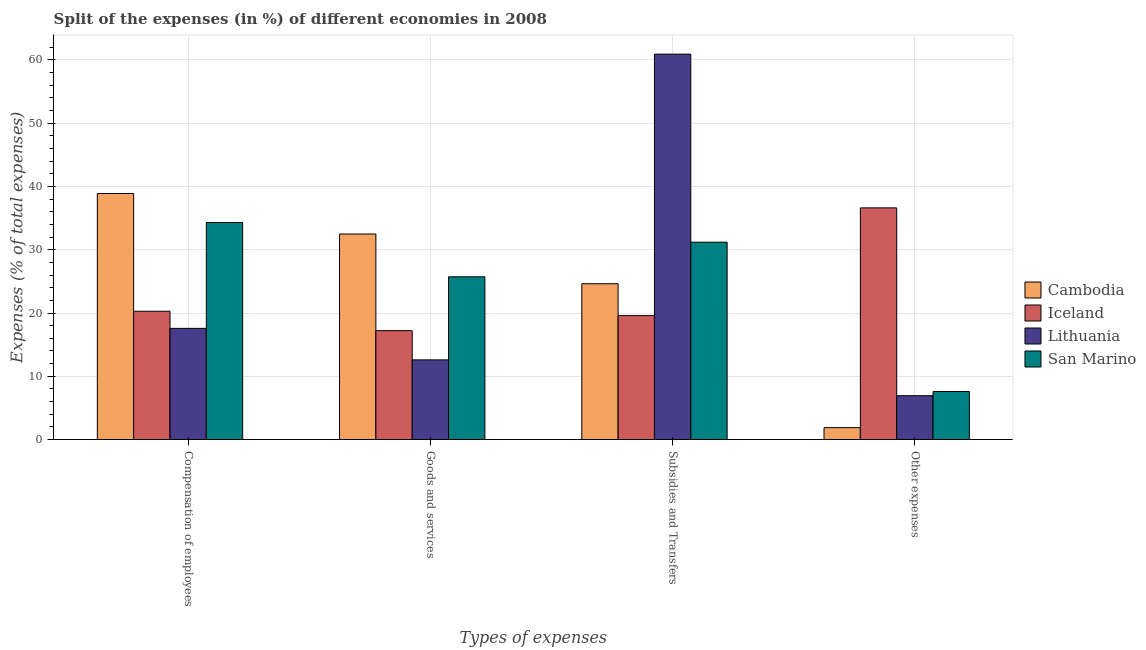How many different coloured bars are there?
Your answer should be very brief. 4. How many groups of bars are there?
Your answer should be very brief. 4. Are the number of bars per tick equal to the number of legend labels?
Your answer should be very brief. Yes. Are the number of bars on each tick of the X-axis equal?
Offer a very short reply. Yes. How many bars are there on the 4th tick from the right?
Provide a short and direct response. 4. What is the label of the 2nd group of bars from the left?
Your answer should be compact. Goods and services. What is the percentage of amount spent on subsidies in Lithuania?
Make the answer very short. 60.9. Across all countries, what is the maximum percentage of amount spent on other expenses?
Make the answer very short. 36.61. Across all countries, what is the minimum percentage of amount spent on subsidies?
Provide a succinct answer. 19.6. In which country was the percentage of amount spent on goods and services maximum?
Ensure brevity in your answer.  Cambodia. In which country was the percentage of amount spent on goods and services minimum?
Provide a succinct answer. Lithuania. What is the total percentage of amount spent on other expenses in the graph?
Give a very brief answer. 53.04. What is the difference between the percentage of amount spent on subsidies in Lithuania and that in Cambodia?
Ensure brevity in your answer.  36.27. What is the difference between the percentage of amount spent on other expenses in Iceland and the percentage of amount spent on goods and services in Cambodia?
Make the answer very short. 4.13. What is the average percentage of amount spent on compensation of employees per country?
Provide a succinct answer. 27.76. What is the difference between the percentage of amount spent on other expenses and percentage of amount spent on subsidies in Iceland?
Your response must be concise. 17.02. What is the ratio of the percentage of amount spent on goods and services in Cambodia to that in Iceland?
Provide a short and direct response. 1.89. Is the percentage of amount spent on goods and services in San Marino less than that in Lithuania?
Give a very brief answer. No. What is the difference between the highest and the second highest percentage of amount spent on goods and services?
Your answer should be very brief. 6.76. What is the difference between the highest and the lowest percentage of amount spent on compensation of employees?
Ensure brevity in your answer.  21.31. Is it the case that in every country, the sum of the percentage of amount spent on compensation of employees and percentage of amount spent on other expenses is greater than the sum of percentage of amount spent on subsidies and percentage of amount spent on goods and services?
Provide a succinct answer. No. What does the 3rd bar from the left in Goods and services represents?
Keep it short and to the point. Lithuania. What does the 1st bar from the right in Goods and services represents?
Provide a succinct answer. San Marino. How many countries are there in the graph?
Your answer should be compact. 4. Are the values on the major ticks of Y-axis written in scientific E-notation?
Offer a very short reply. No. Does the graph contain grids?
Make the answer very short. Yes. How many legend labels are there?
Ensure brevity in your answer.  4. What is the title of the graph?
Your response must be concise. Split of the expenses (in %) of different economies in 2008. Does "Jordan" appear as one of the legend labels in the graph?
Ensure brevity in your answer.  No. What is the label or title of the X-axis?
Ensure brevity in your answer.  Types of expenses. What is the label or title of the Y-axis?
Your answer should be compact. Expenses (% of total expenses). What is the Expenses (% of total expenses) in Cambodia in Compensation of employees?
Your response must be concise. 38.88. What is the Expenses (% of total expenses) of Iceland in Compensation of employees?
Give a very brief answer. 20.28. What is the Expenses (% of total expenses) of Lithuania in Compensation of employees?
Keep it short and to the point. 17.57. What is the Expenses (% of total expenses) of San Marino in Compensation of employees?
Your answer should be compact. 34.3. What is the Expenses (% of total expenses) in Cambodia in Goods and services?
Make the answer very short. 32.48. What is the Expenses (% of total expenses) of Iceland in Goods and services?
Keep it short and to the point. 17.22. What is the Expenses (% of total expenses) in Lithuania in Goods and services?
Make the answer very short. 12.6. What is the Expenses (% of total expenses) in San Marino in Goods and services?
Give a very brief answer. 25.72. What is the Expenses (% of total expenses) of Cambodia in Subsidies and Transfers?
Keep it short and to the point. 24.63. What is the Expenses (% of total expenses) in Iceland in Subsidies and Transfers?
Your response must be concise. 19.6. What is the Expenses (% of total expenses) of Lithuania in Subsidies and Transfers?
Ensure brevity in your answer.  60.9. What is the Expenses (% of total expenses) in San Marino in Subsidies and Transfers?
Provide a succinct answer. 31.19. What is the Expenses (% of total expenses) in Cambodia in Other expenses?
Ensure brevity in your answer.  1.89. What is the Expenses (% of total expenses) of Iceland in Other expenses?
Give a very brief answer. 36.61. What is the Expenses (% of total expenses) of Lithuania in Other expenses?
Offer a terse response. 6.94. What is the Expenses (% of total expenses) of San Marino in Other expenses?
Ensure brevity in your answer.  7.6. Across all Types of expenses, what is the maximum Expenses (% of total expenses) in Cambodia?
Offer a terse response. 38.88. Across all Types of expenses, what is the maximum Expenses (% of total expenses) in Iceland?
Offer a very short reply. 36.61. Across all Types of expenses, what is the maximum Expenses (% of total expenses) in Lithuania?
Provide a short and direct response. 60.9. Across all Types of expenses, what is the maximum Expenses (% of total expenses) of San Marino?
Offer a terse response. 34.3. Across all Types of expenses, what is the minimum Expenses (% of total expenses) in Cambodia?
Keep it short and to the point. 1.89. Across all Types of expenses, what is the minimum Expenses (% of total expenses) in Iceland?
Offer a very short reply. 17.22. Across all Types of expenses, what is the minimum Expenses (% of total expenses) of Lithuania?
Keep it short and to the point. 6.94. Across all Types of expenses, what is the minimum Expenses (% of total expenses) in San Marino?
Offer a very short reply. 7.6. What is the total Expenses (% of total expenses) of Cambodia in the graph?
Provide a succinct answer. 97.88. What is the total Expenses (% of total expenses) of Iceland in the graph?
Give a very brief answer. 93.7. What is the total Expenses (% of total expenses) of Lithuania in the graph?
Keep it short and to the point. 98.01. What is the total Expenses (% of total expenses) of San Marino in the graph?
Offer a terse response. 98.81. What is the difference between the Expenses (% of total expenses) in Cambodia in Compensation of employees and that in Goods and services?
Ensure brevity in your answer.  6.4. What is the difference between the Expenses (% of total expenses) of Iceland in Compensation of employees and that in Goods and services?
Give a very brief answer. 3.06. What is the difference between the Expenses (% of total expenses) in Lithuania in Compensation of employees and that in Goods and services?
Keep it short and to the point. 4.98. What is the difference between the Expenses (% of total expenses) in San Marino in Compensation of employees and that in Goods and services?
Give a very brief answer. 8.58. What is the difference between the Expenses (% of total expenses) in Cambodia in Compensation of employees and that in Subsidies and Transfers?
Your response must be concise. 14.25. What is the difference between the Expenses (% of total expenses) of Iceland in Compensation of employees and that in Subsidies and Transfers?
Ensure brevity in your answer.  0.68. What is the difference between the Expenses (% of total expenses) in Lithuania in Compensation of employees and that in Subsidies and Transfers?
Provide a succinct answer. -43.33. What is the difference between the Expenses (% of total expenses) of San Marino in Compensation of employees and that in Subsidies and Transfers?
Provide a succinct answer. 3.11. What is the difference between the Expenses (% of total expenses) of Cambodia in Compensation of employees and that in Other expenses?
Your response must be concise. 37. What is the difference between the Expenses (% of total expenses) of Iceland in Compensation of employees and that in Other expenses?
Offer a very short reply. -16.33. What is the difference between the Expenses (% of total expenses) of Lithuania in Compensation of employees and that in Other expenses?
Provide a short and direct response. 10.64. What is the difference between the Expenses (% of total expenses) of San Marino in Compensation of employees and that in Other expenses?
Your answer should be very brief. 26.7. What is the difference between the Expenses (% of total expenses) of Cambodia in Goods and services and that in Subsidies and Transfers?
Offer a terse response. 7.85. What is the difference between the Expenses (% of total expenses) in Iceland in Goods and services and that in Subsidies and Transfers?
Offer a very short reply. -2.38. What is the difference between the Expenses (% of total expenses) of Lithuania in Goods and services and that in Subsidies and Transfers?
Ensure brevity in your answer.  -48.3. What is the difference between the Expenses (% of total expenses) in San Marino in Goods and services and that in Subsidies and Transfers?
Your answer should be compact. -5.47. What is the difference between the Expenses (% of total expenses) of Cambodia in Goods and services and that in Other expenses?
Keep it short and to the point. 30.59. What is the difference between the Expenses (% of total expenses) of Iceland in Goods and services and that in Other expenses?
Ensure brevity in your answer.  -19.4. What is the difference between the Expenses (% of total expenses) in Lithuania in Goods and services and that in Other expenses?
Offer a very short reply. 5.66. What is the difference between the Expenses (% of total expenses) of San Marino in Goods and services and that in Other expenses?
Ensure brevity in your answer.  18.12. What is the difference between the Expenses (% of total expenses) of Cambodia in Subsidies and Transfers and that in Other expenses?
Offer a very short reply. 22.74. What is the difference between the Expenses (% of total expenses) of Iceland in Subsidies and Transfers and that in Other expenses?
Ensure brevity in your answer.  -17.02. What is the difference between the Expenses (% of total expenses) in Lithuania in Subsidies and Transfers and that in Other expenses?
Give a very brief answer. 53.96. What is the difference between the Expenses (% of total expenses) of San Marino in Subsidies and Transfers and that in Other expenses?
Ensure brevity in your answer.  23.59. What is the difference between the Expenses (% of total expenses) of Cambodia in Compensation of employees and the Expenses (% of total expenses) of Iceland in Goods and services?
Provide a succinct answer. 21.67. What is the difference between the Expenses (% of total expenses) of Cambodia in Compensation of employees and the Expenses (% of total expenses) of Lithuania in Goods and services?
Offer a very short reply. 26.29. What is the difference between the Expenses (% of total expenses) of Cambodia in Compensation of employees and the Expenses (% of total expenses) of San Marino in Goods and services?
Offer a very short reply. 13.16. What is the difference between the Expenses (% of total expenses) in Iceland in Compensation of employees and the Expenses (% of total expenses) in Lithuania in Goods and services?
Give a very brief answer. 7.68. What is the difference between the Expenses (% of total expenses) in Iceland in Compensation of employees and the Expenses (% of total expenses) in San Marino in Goods and services?
Keep it short and to the point. -5.44. What is the difference between the Expenses (% of total expenses) in Lithuania in Compensation of employees and the Expenses (% of total expenses) in San Marino in Goods and services?
Provide a succinct answer. -8.15. What is the difference between the Expenses (% of total expenses) of Cambodia in Compensation of employees and the Expenses (% of total expenses) of Iceland in Subsidies and Transfers?
Your answer should be very brief. 19.29. What is the difference between the Expenses (% of total expenses) in Cambodia in Compensation of employees and the Expenses (% of total expenses) in Lithuania in Subsidies and Transfers?
Your answer should be very brief. -22.02. What is the difference between the Expenses (% of total expenses) of Cambodia in Compensation of employees and the Expenses (% of total expenses) of San Marino in Subsidies and Transfers?
Your answer should be compact. 7.69. What is the difference between the Expenses (% of total expenses) of Iceland in Compensation of employees and the Expenses (% of total expenses) of Lithuania in Subsidies and Transfers?
Your answer should be compact. -40.62. What is the difference between the Expenses (% of total expenses) of Iceland in Compensation of employees and the Expenses (% of total expenses) of San Marino in Subsidies and Transfers?
Make the answer very short. -10.91. What is the difference between the Expenses (% of total expenses) of Lithuania in Compensation of employees and the Expenses (% of total expenses) of San Marino in Subsidies and Transfers?
Keep it short and to the point. -13.62. What is the difference between the Expenses (% of total expenses) of Cambodia in Compensation of employees and the Expenses (% of total expenses) of Iceland in Other expenses?
Offer a very short reply. 2.27. What is the difference between the Expenses (% of total expenses) of Cambodia in Compensation of employees and the Expenses (% of total expenses) of Lithuania in Other expenses?
Make the answer very short. 31.95. What is the difference between the Expenses (% of total expenses) in Cambodia in Compensation of employees and the Expenses (% of total expenses) in San Marino in Other expenses?
Keep it short and to the point. 31.28. What is the difference between the Expenses (% of total expenses) in Iceland in Compensation of employees and the Expenses (% of total expenses) in Lithuania in Other expenses?
Make the answer very short. 13.34. What is the difference between the Expenses (% of total expenses) of Iceland in Compensation of employees and the Expenses (% of total expenses) of San Marino in Other expenses?
Keep it short and to the point. 12.68. What is the difference between the Expenses (% of total expenses) of Lithuania in Compensation of employees and the Expenses (% of total expenses) of San Marino in Other expenses?
Provide a succinct answer. 9.98. What is the difference between the Expenses (% of total expenses) of Cambodia in Goods and services and the Expenses (% of total expenses) of Iceland in Subsidies and Transfers?
Give a very brief answer. 12.89. What is the difference between the Expenses (% of total expenses) of Cambodia in Goods and services and the Expenses (% of total expenses) of Lithuania in Subsidies and Transfers?
Your response must be concise. -28.42. What is the difference between the Expenses (% of total expenses) in Cambodia in Goods and services and the Expenses (% of total expenses) in San Marino in Subsidies and Transfers?
Your response must be concise. 1.29. What is the difference between the Expenses (% of total expenses) of Iceland in Goods and services and the Expenses (% of total expenses) of Lithuania in Subsidies and Transfers?
Offer a terse response. -43.68. What is the difference between the Expenses (% of total expenses) of Iceland in Goods and services and the Expenses (% of total expenses) of San Marino in Subsidies and Transfers?
Your answer should be very brief. -13.98. What is the difference between the Expenses (% of total expenses) of Lithuania in Goods and services and the Expenses (% of total expenses) of San Marino in Subsidies and Transfers?
Keep it short and to the point. -18.6. What is the difference between the Expenses (% of total expenses) of Cambodia in Goods and services and the Expenses (% of total expenses) of Iceland in Other expenses?
Your response must be concise. -4.13. What is the difference between the Expenses (% of total expenses) of Cambodia in Goods and services and the Expenses (% of total expenses) of Lithuania in Other expenses?
Offer a very short reply. 25.54. What is the difference between the Expenses (% of total expenses) of Cambodia in Goods and services and the Expenses (% of total expenses) of San Marino in Other expenses?
Offer a very short reply. 24.88. What is the difference between the Expenses (% of total expenses) in Iceland in Goods and services and the Expenses (% of total expenses) in Lithuania in Other expenses?
Ensure brevity in your answer.  10.28. What is the difference between the Expenses (% of total expenses) of Iceland in Goods and services and the Expenses (% of total expenses) of San Marino in Other expenses?
Make the answer very short. 9.62. What is the difference between the Expenses (% of total expenses) in Lithuania in Goods and services and the Expenses (% of total expenses) in San Marino in Other expenses?
Provide a succinct answer. 5. What is the difference between the Expenses (% of total expenses) in Cambodia in Subsidies and Transfers and the Expenses (% of total expenses) in Iceland in Other expenses?
Give a very brief answer. -11.98. What is the difference between the Expenses (% of total expenses) in Cambodia in Subsidies and Transfers and the Expenses (% of total expenses) in Lithuania in Other expenses?
Keep it short and to the point. 17.69. What is the difference between the Expenses (% of total expenses) in Cambodia in Subsidies and Transfers and the Expenses (% of total expenses) in San Marino in Other expenses?
Your answer should be very brief. 17.03. What is the difference between the Expenses (% of total expenses) in Iceland in Subsidies and Transfers and the Expenses (% of total expenses) in Lithuania in Other expenses?
Keep it short and to the point. 12.66. What is the difference between the Expenses (% of total expenses) of Iceland in Subsidies and Transfers and the Expenses (% of total expenses) of San Marino in Other expenses?
Make the answer very short. 12. What is the difference between the Expenses (% of total expenses) in Lithuania in Subsidies and Transfers and the Expenses (% of total expenses) in San Marino in Other expenses?
Your answer should be very brief. 53.3. What is the average Expenses (% of total expenses) in Cambodia per Types of expenses?
Offer a very short reply. 24.47. What is the average Expenses (% of total expenses) of Iceland per Types of expenses?
Give a very brief answer. 23.43. What is the average Expenses (% of total expenses) of Lithuania per Types of expenses?
Ensure brevity in your answer.  24.5. What is the average Expenses (% of total expenses) in San Marino per Types of expenses?
Your answer should be compact. 24.7. What is the difference between the Expenses (% of total expenses) of Cambodia and Expenses (% of total expenses) of Iceland in Compensation of employees?
Your answer should be compact. 18.6. What is the difference between the Expenses (% of total expenses) in Cambodia and Expenses (% of total expenses) in Lithuania in Compensation of employees?
Offer a terse response. 21.31. What is the difference between the Expenses (% of total expenses) in Cambodia and Expenses (% of total expenses) in San Marino in Compensation of employees?
Keep it short and to the point. 4.59. What is the difference between the Expenses (% of total expenses) of Iceland and Expenses (% of total expenses) of Lithuania in Compensation of employees?
Make the answer very short. 2.7. What is the difference between the Expenses (% of total expenses) in Iceland and Expenses (% of total expenses) in San Marino in Compensation of employees?
Your response must be concise. -14.02. What is the difference between the Expenses (% of total expenses) of Lithuania and Expenses (% of total expenses) of San Marino in Compensation of employees?
Your response must be concise. -16.72. What is the difference between the Expenses (% of total expenses) of Cambodia and Expenses (% of total expenses) of Iceland in Goods and services?
Offer a very short reply. 15.27. What is the difference between the Expenses (% of total expenses) in Cambodia and Expenses (% of total expenses) in Lithuania in Goods and services?
Offer a very short reply. 19.88. What is the difference between the Expenses (% of total expenses) in Cambodia and Expenses (% of total expenses) in San Marino in Goods and services?
Your answer should be compact. 6.76. What is the difference between the Expenses (% of total expenses) of Iceland and Expenses (% of total expenses) of Lithuania in Goods and services?
Your answer should be very brief. 4.62. What is the difference between the Expenses (% of total expenses) of Iceland and Expenses (% of total expenses) of San Marino in Goods and services?
Keep it short and to the point. -8.51. What is the difference between the Expenses (% of total expenses) of Lithuania and Expenses (% of total expenses) of San Marino in Goods and services?
Provide a short and direct response. -13.12. What is the difference between the Expenses (% of total expenses) in Cambodia and Expenses (% of total expenses) in Iceland in Subsidies and Transfers?
Your answer should be compact. 5.03. What is the difference between the Expenses (% of total expenses) of Cambodia and Expenses (% of total expenses) of Lithuania in Subsidies and Transfers?
Your response must be concise. -36.27. What is the difference between the Expenses (% of total expenses) of Cambodia and Expenses (% of total expenses) of San Marino in Subsidies and Transfers?
Offer a terse response. -6.56. What is the difference between the Expenses (% of total expenses) in Iceland and Expenses (% of total expenses) in Lithuania in Subsidies and Transfers?
Your answer should be very brief. -41.3. What is the difference between the Expenses (% of total expenses) in Iceland and Expenses (% of total expenses) in San Marino in Subsidies and Transfers?
Ensure brevity in your answer.  -11.6. What is the difference between the Expenses (% of total expenses) of Lithuania and Expenses (% of total expenses) of San Marino in Subsidies and Transfers?
Provide a short and direct response. 29.71. What is the difference between the Expenses (% of total expenses) of Cambodia and Expenses (% of total expenses) of Iceland in Other expenses?
Your answer should be very brief. -34.72. What is the difference between the Expenses (% of total expenses) of Cambodia and Expenses (% of total expenses) of Lithuania in Other expenses?
Offer a terse response. -5.05. What is the difference between the Expenses (% of total expenses) of Cambodia and Expenses (% of total expenses) of San Marino in Other expenses?
Offer a terse response. -5.71. What is the difference between the Expenses (% of total expenses) in Iceland and Expenses (% of total expenses) in Lithuania in Other expenses?
Provide a short and direct response. 29.67. What is the difference between the Expenses (% of total expenses) in Iceland and Expenses (% of total expenses) in San Marino in Other expenses?
Your answer should be very brief. 29.01. What is the difference between the Expenses (% of total expenses) in Lithuania and Expenses (% of total expenses) in San Marino in Other expenses?
Provide a short and direct response. -0.66. What is the ratio of the Expenses (% of total expenses) in Cambodia in Compensation of employees to that in Goods and services?
Your answer should be very brief. 1.2. What is the ratio of the Expenses (% of total expenses) of Iceland in Compensation of employees to that in Goods and services?
Offer a very short reply. 1.18. What is the ratio of the Expenses (% of total expenses) of Lithuania in Compensation of employees to that in Goods and services?
Provide a succinct answer. 1.4. What is the ratio of the Expenses (% of total expenses) in San Marino in Compensation of employees to that in Goods and services?
Offer a terse response. 1.33. What is the ratio of the Expenses (% of total expenses) in Cambodia in Compensation of employees to that in Subsidies and Transfers?
Provide a short and direct response. 1.58. What is the ratio of the Expenses (% of total expenses) of Iceland in Compensation of employees to that in Subsidies and Transfers?
Your answer should be very brief. 1.03. What is the ratio of the Expenses (% of total expenses) in Lithuania in Compensation of employees to that in Subsidies and Transfers?
Offer a very short reply. 0.29. What is the ratio of the Expenses (% of total expenses) in San Marino in Compensation of employees to that in Subsidies and Transfers?
Your response must be concise. 1.1. What is the ratio of the Expenses (% of total expenses) of Cambodia in Compensation of employees to that in Other expenses?
Make the answer very short. 20.59. What is the ratio of the Expenses (% of total expenses) of Iceland in Compensation of employees to that in Other expenses?
Provide a succinct answer. 0.55. What is the ratio of the Expenses (% of total expenses) of Lithuania in Compensation of employees to that in Other expenses?
Offer a terse response. 2.53. What is the ratio of the Expenses (% of total expenses) in San Marino in Compensation of employees to that in Other expenses?
Provide a succinct answer. 4.51. What is the ratio of the Expenses (% of total expenses) of Cambodia in Goods and services to that in Subsidies and Transfers?
Your answer should be compact. 1.32. What is the ratio of the Expenses (% of total expenses) in Iceland in Goods and services to that in Subsidies and Transfers?
Give a very brief answer. 0.88. What is the ratio of the Expenses (% of total expenses) of Lithuania in Goods and services to that in Subsidies and Transfers?
Offer a very short reply. 0.21. What is the ratio of the Expenses (% of total expenses) in San Marino in Goods and services to that in Subsidies and Transfers?
Offer a very short reply. 0.82. What is the ratio of the Expenses (% of total expenses) of Cambodia in Goods and services to that in Other expenses?
Ensure brevity in your answer.  17.2. What is the ratio of the Expenses (% of total expenses) of Iceland in Goods and services to that in Other expenses?
Your answer should be very brief. 0.47. What is the ratio of the Expenses (% of total expenses) of Lithuania in Goods and services to that in Other expenses?
Make the answer very short. 1.82. What is the ratio of the Expenses (% of total expenses) of San Marino in Goods and services to that in Other expenses?
Your answer should be compact. 3.38. What is the ratio of the Expenses (% of total expenses) of Cambodia in Subsidies and Transfers to that in Other expenses?
Offer a terse response. 13.04. What is the ratio of the Expenses (% of total expenses) in Iceland in Subsidies and Transfers to that in Other expenses?
Provide a succinct answer. 0.54. What is the ratio of the Expenses (% of total expenses) in Lithuania in Subsidies and Transfers to that in Other expenses?
Your answer should be very brief. 8.78. What is the ratio of the Expenses (% of total expenses) in San Marino in Subsidies and Transfers to that in Other expenses?
Provide a short and direct response. 4.1. What is the difference between the highest and the second highest Expenses (% of total expenses) of Cambodia?
Your answer should be compact. 6.4. What is the difference between the highest and the second highest Expenses (% of total expenses) of Iceland?
Make the answer very short. 16.33. What is the difference between the highest and the second highest Expenses (% of total expenses) of Lithuania?
Give a very brief answer. 43.33. What is the difference between the highest and the second highest Expenses (% of total expenses) in San Marino?
Ensure brevity in your answer.  3.11. What is the difference between the highest and the lowest Expenses (% of total expenses) of Cambodia?
Make the answer very short. 37. What is the difference between the highest and the lowest Expenses (% of total expenses) of Iceland?
Offer a terse response. 19.4. What is the difference between the highest and the lowest Expenses (% of total expenses) in Lithuania?
Your response must be concise. 53.96. What is the difference between the highest and the lowest Expenses (% of total expenses) in San Marino?
Ensure brevity in your answer.  26.7. 